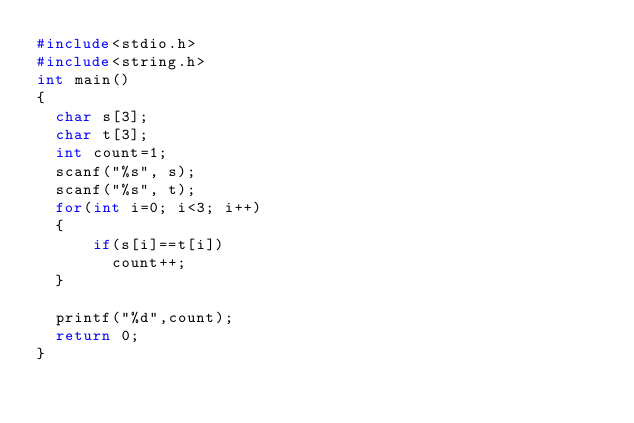<code> <loc_0><loc_0><loc_500><loc_500><_C_>#include<stdio.h>
#include<string.h>
int main()
{
  char s[3];
  char t[3];
  int count=1;
  scanf("%s", s);
  scanf("%s", t);
  for(int i=0; i<3; i++)
  {
      if(s[i]==t[i])
        count++;
  }

  printf("%d",count);
  return 0;
}
</code> 